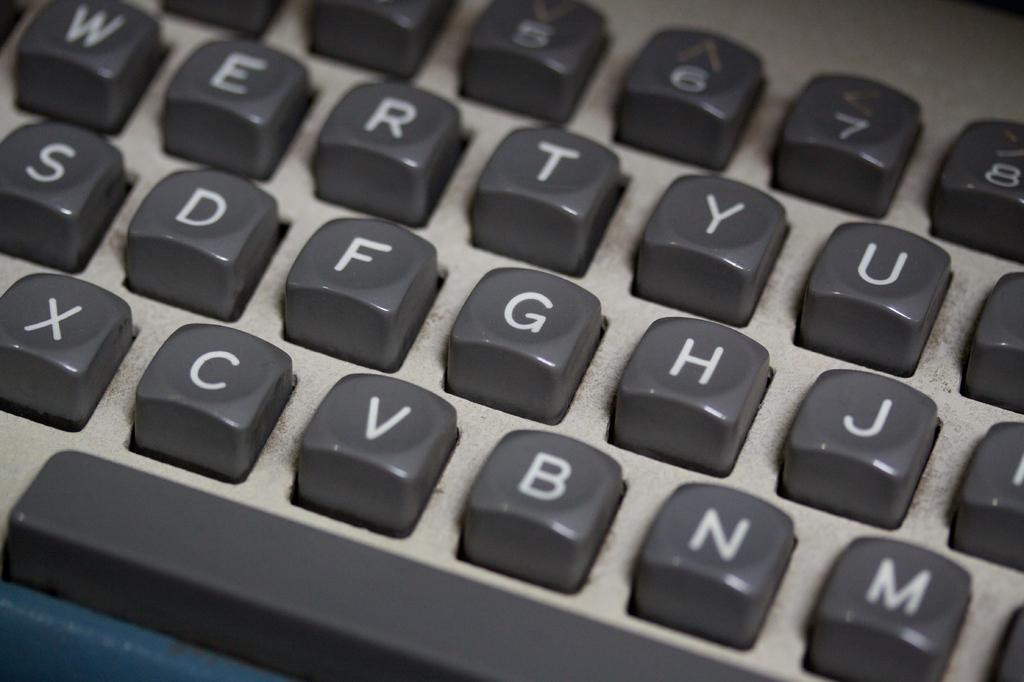<image>
Provide a brief description of the given image. Black keyboard letters of a keyboard in the usual QWERTY arrangement. 